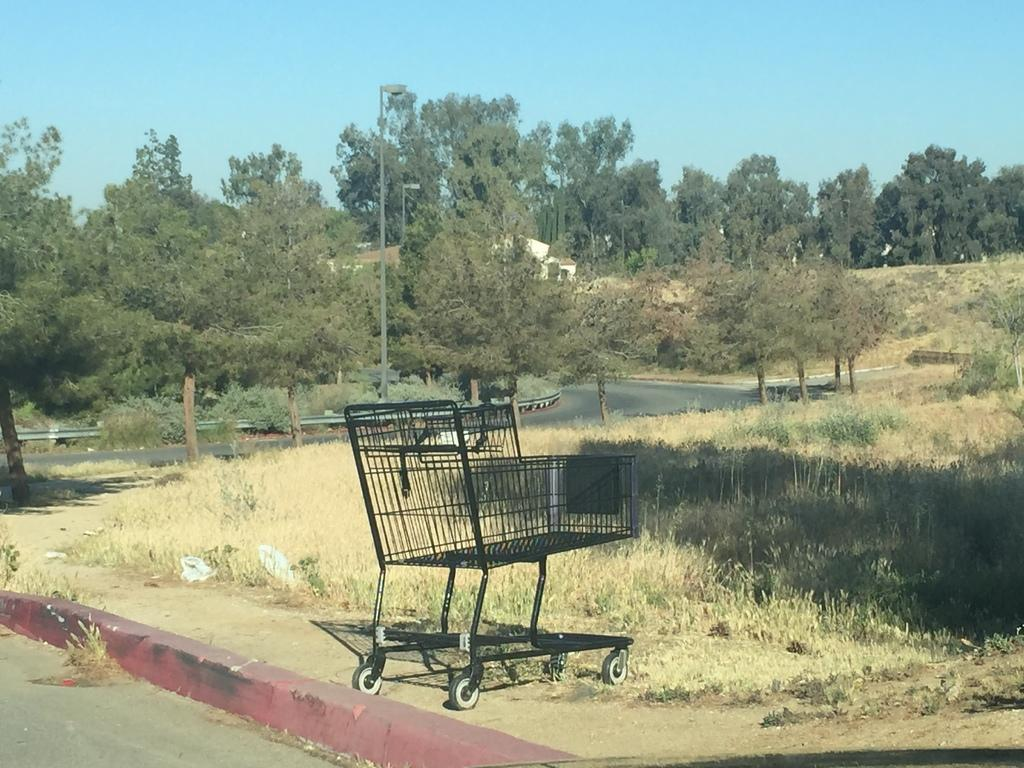What type of pathway can be seen in the image? There is a road in the image. What can be seen beneath the road? The ground is visible in the image. What mode of transportation is present in the image? There is a black-colored trolley in the image. What safety feature is present along the road? The railing is present in the image. What type of vegetation is visible in the image? There are green trees in the image. What type of structures can be seen in the image? There are buildings in the image. What is visible in the background of the image? The sky is visible in the background of the image. Where is the sink located in the image? There is no sink present in the image. What type of offer is being made by the buildings in the image? There are no offers being made by the buildings in the image; they are simply structures. 